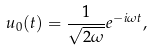Convert formula to latex. <formula><loc_0><loc_0><loc_500><loc_500>u _ { 0 } ( t ) = \frac { 1 } { \sqrt { 2 \omega } } e ^ { - i \omega t } ,</formula> 